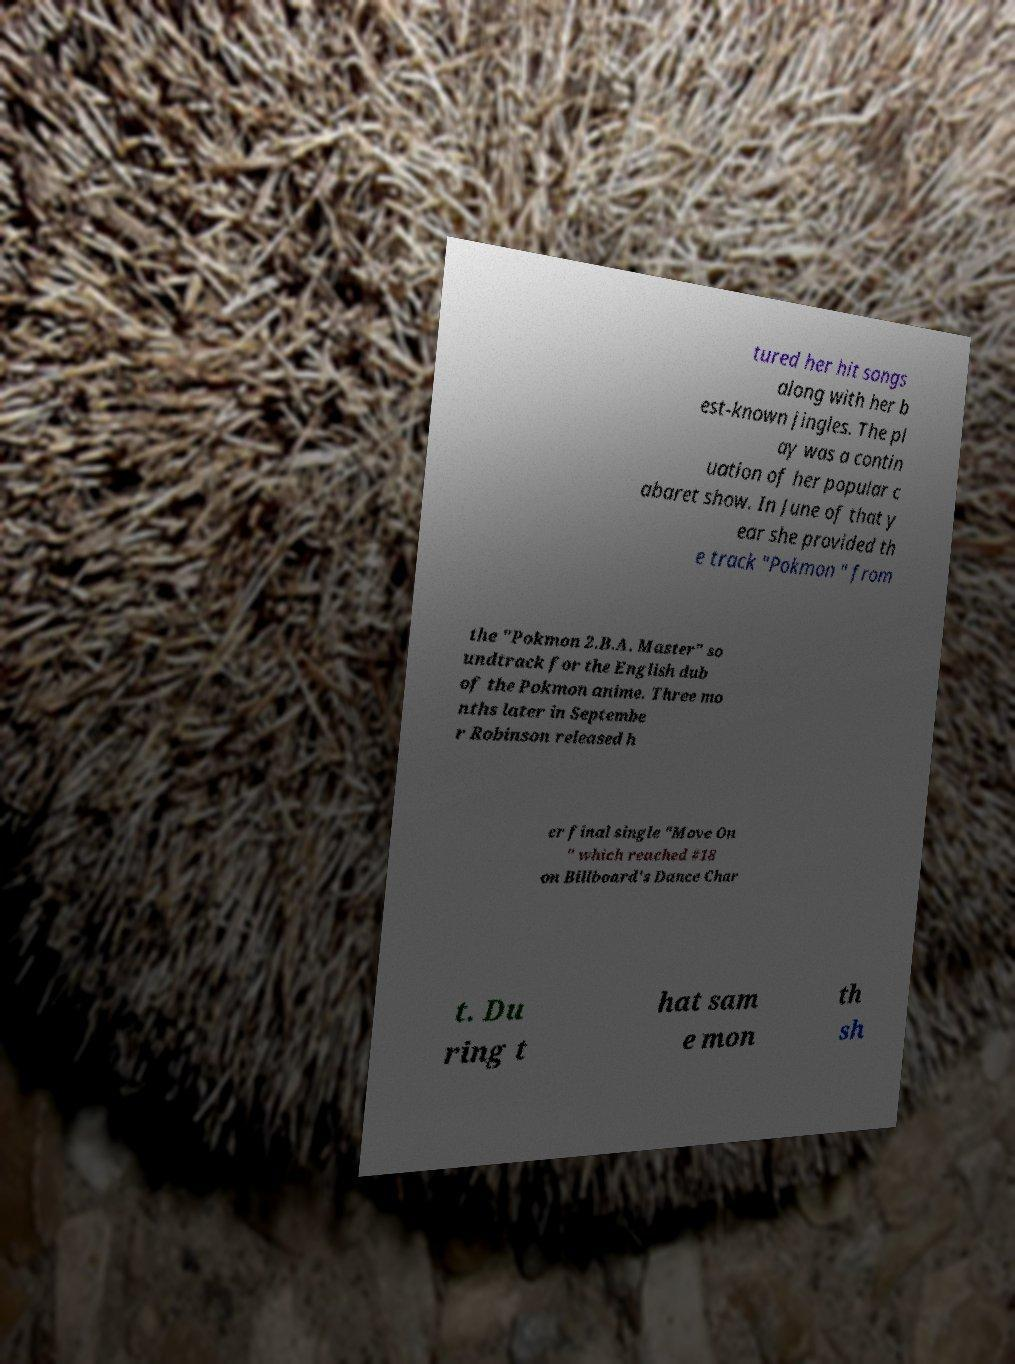What messages or text are displayed in this image? I need them in a readable, typed format. tured her hit songs along with her b est-known jingles. The pl ay was a contin uation of her popular c abaret show. In June of that y ear she provided th e track "Pokmon " from the "Pokmon 2.B.A. Master" so undtrack for the English dub of the Pokmon anime. Three mo nths later in Septembe r Robinson released h er final single "Move On " which reached #18 on Billboard's Dance Char t. Du ring t hat sam e mon th sh 